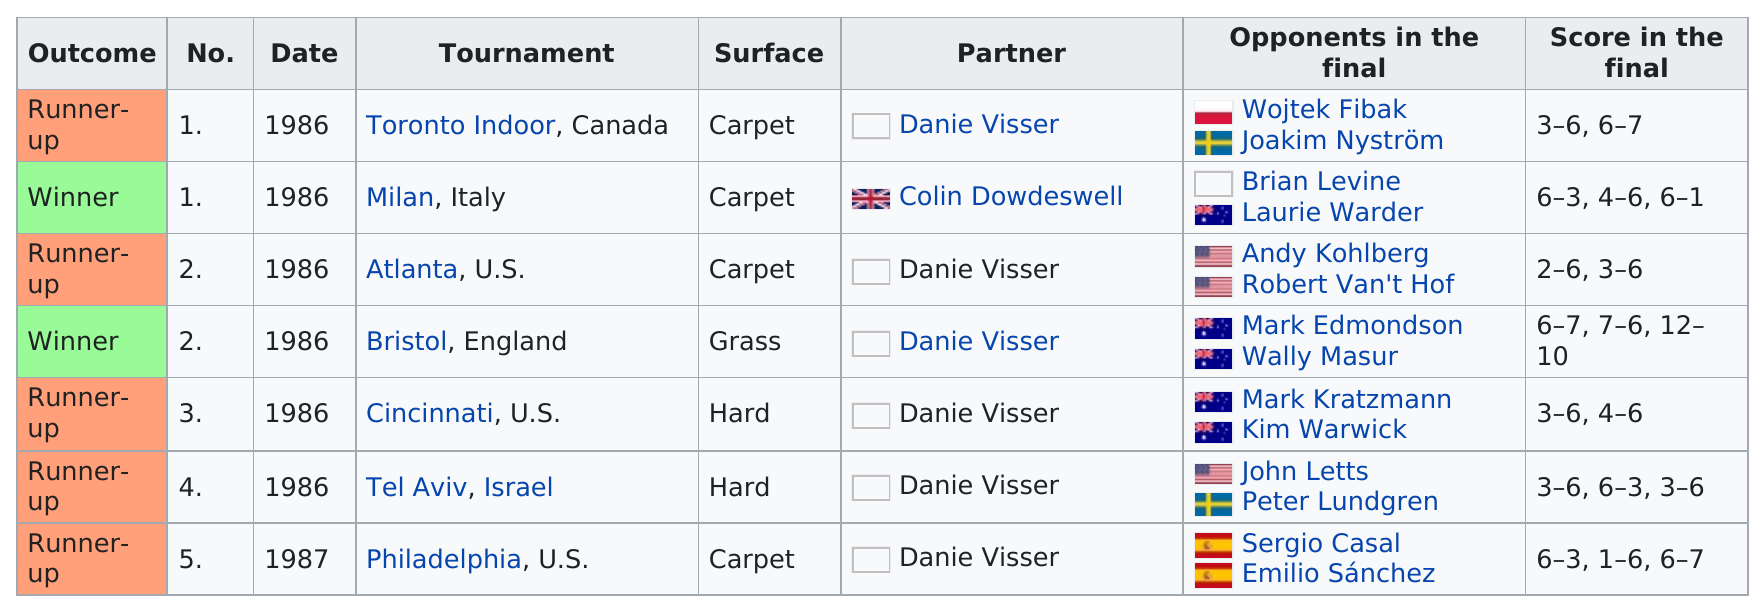Identify some key points in this picture. The first runner-up was listed on what date in 1986? The total of grass and hard surfaces listed is 3. The Philadelphia tournament was the only one held in 1987, and it took place in the United States. The last partner listed is Danie Visser. 